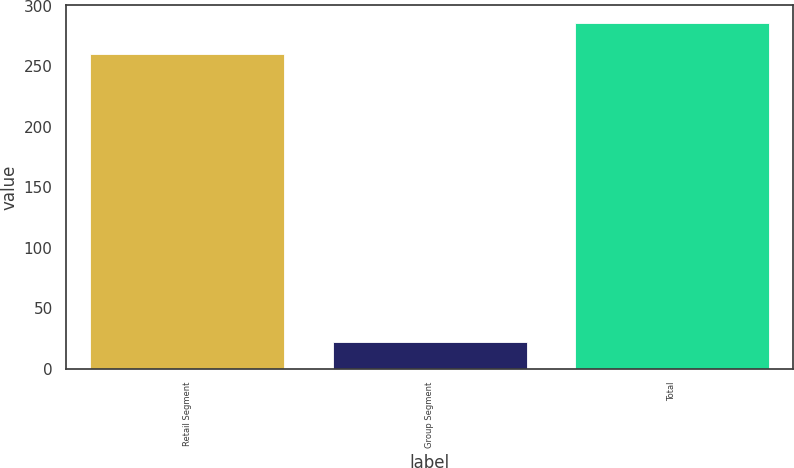Convert chart. <chart><loc_0><loc_0><loc_500><loc_500><bar_chart><fcel>Retail Segment<fcel>Group Segment<fcel>Total<nl><fcel>260<fcel>22<fcel>286<nl></chart> 